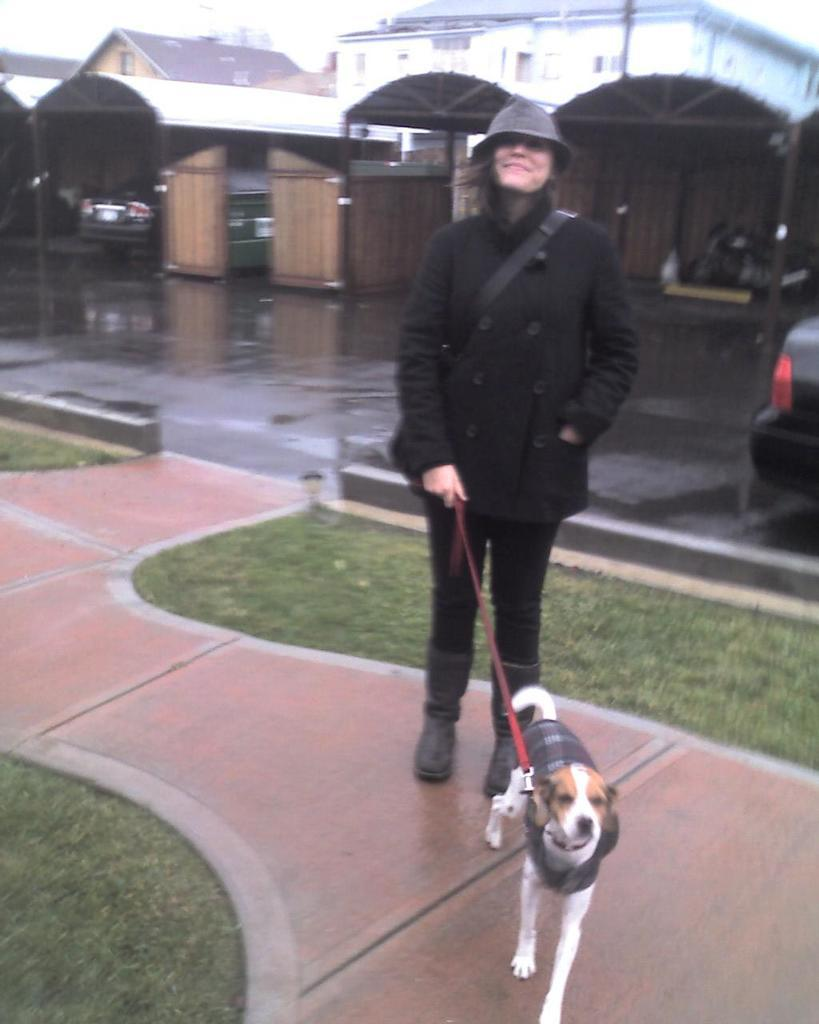What is the person in the image doing? The person is standing in the image and holding a dog's belt. What can be seen in the background of the image? There are sheds, vehicles, houses, a road, and the sky visible in the background of the image. What type of dress is the person wearing on the throne in the image? There is no throne or dress present in the image; the person is standing and holding a dog's belt. 